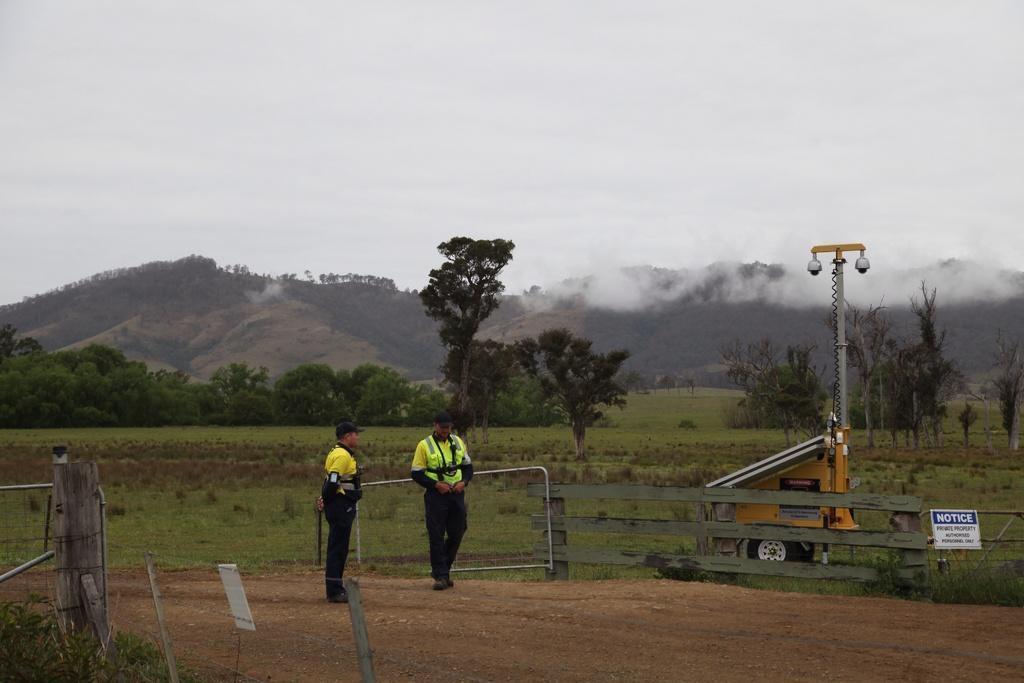Could you give a brief overview of what you see in this image? In the image in the center, we can see two persons are standing. And we can see the banners, fences and one vehicle. In the background, we can see the sky, clouds, trees, hills, smoke, plants and grass. 